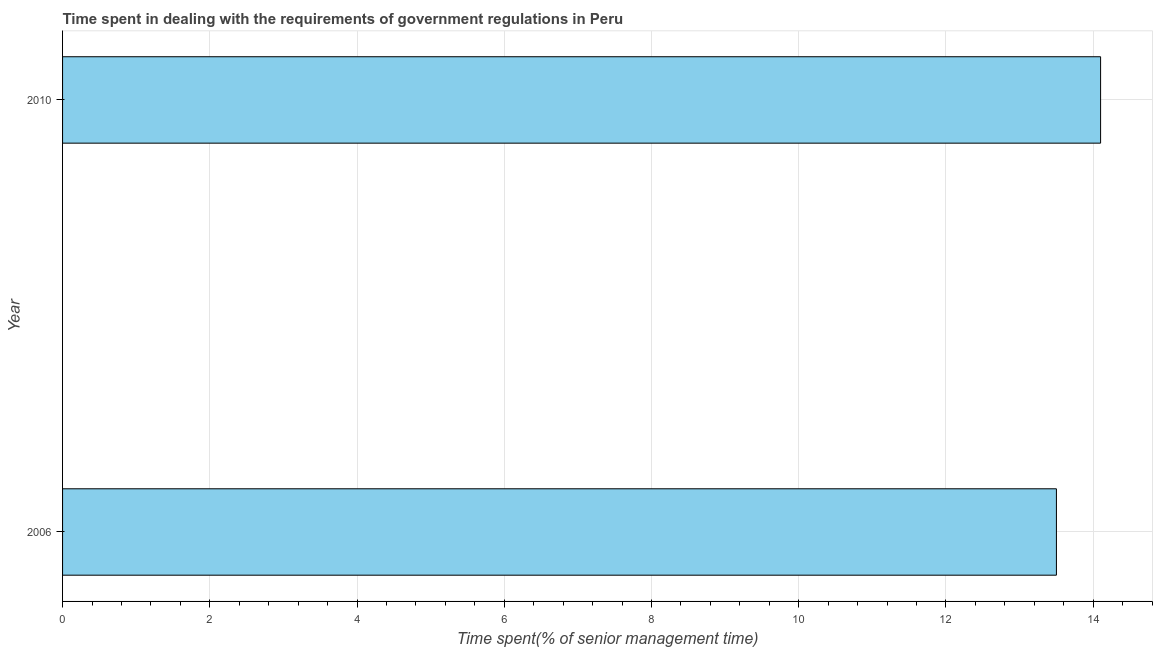Does the graph contain any zero values?
Ensure brevity in your answer.  No. Does the graph contain grids?
Your response must be concise. Yes. What is the title of the graph?
Give a very brief answer. Time spent in dealing with the requirements of government regulations in Peru. What is the label or title of the X-axis?
Offer a very short reply. Time spent(% of senior management time). What is the label or title of the Y-axis?
Provide a succinct answer. Year. What is the time spent in dealing with government regulations in 2006?
Provide a succinct answer. 13.5. Across all years, what is the maximum time spent in dealing with government regulations?
Your answer should be very brief. 14.1. Across all years, what is the minimum time spent in dealing with government regulations?
Ensure brevity in your answer.  13.5. In which year was the time spent in dealing with government regulations maximum?
Your answer should be very brief. 2010. In which year was the time spent in dealing with government regulations minimum?
Offer a very short reply. 2006. What is the sum of the time spent in dealing with government regulations?
Ensure brevity in your answer.  27.6. What is the difference between the time spent in dealing with government regulations in 2006 and 2010?
Make the answer very short. -0.6. What is the average time spent in dealing with government regulations per year?
Your answer should be compact. 13.8. What is the median time spent in dealing with government regulations?
Your answer should be very brief. 13.8. Do a majority of the years between 2006 and 2010 (inclusive) have time spent in dealing with government regulations greater than 11.6 %?
Provide a short and direct response. Yes. What is the ratio of the time spent in dealing with government regulations in 2006 to that in 2010?
Give a very brief answer. 0.96. Is the time spent in dealing with government regulations in 2006 less than that in 2010?
Your response must be concise. Yes. In how many years, is the time spent in dealing with government regulations greater than the average time spent in dealing with government regulations taken over all years?
Your answer should be compact. 1. How many bars are there?
Offer a very short reply. 2. Are all the bars in the graph horizontal?
Ensure brevity in your answer.  Yes. How many years are there in the graph?
Your response must be concise. 2. What is the Time spent(% of senior management time) of 2006?
Your response must be concise. 13.5. 